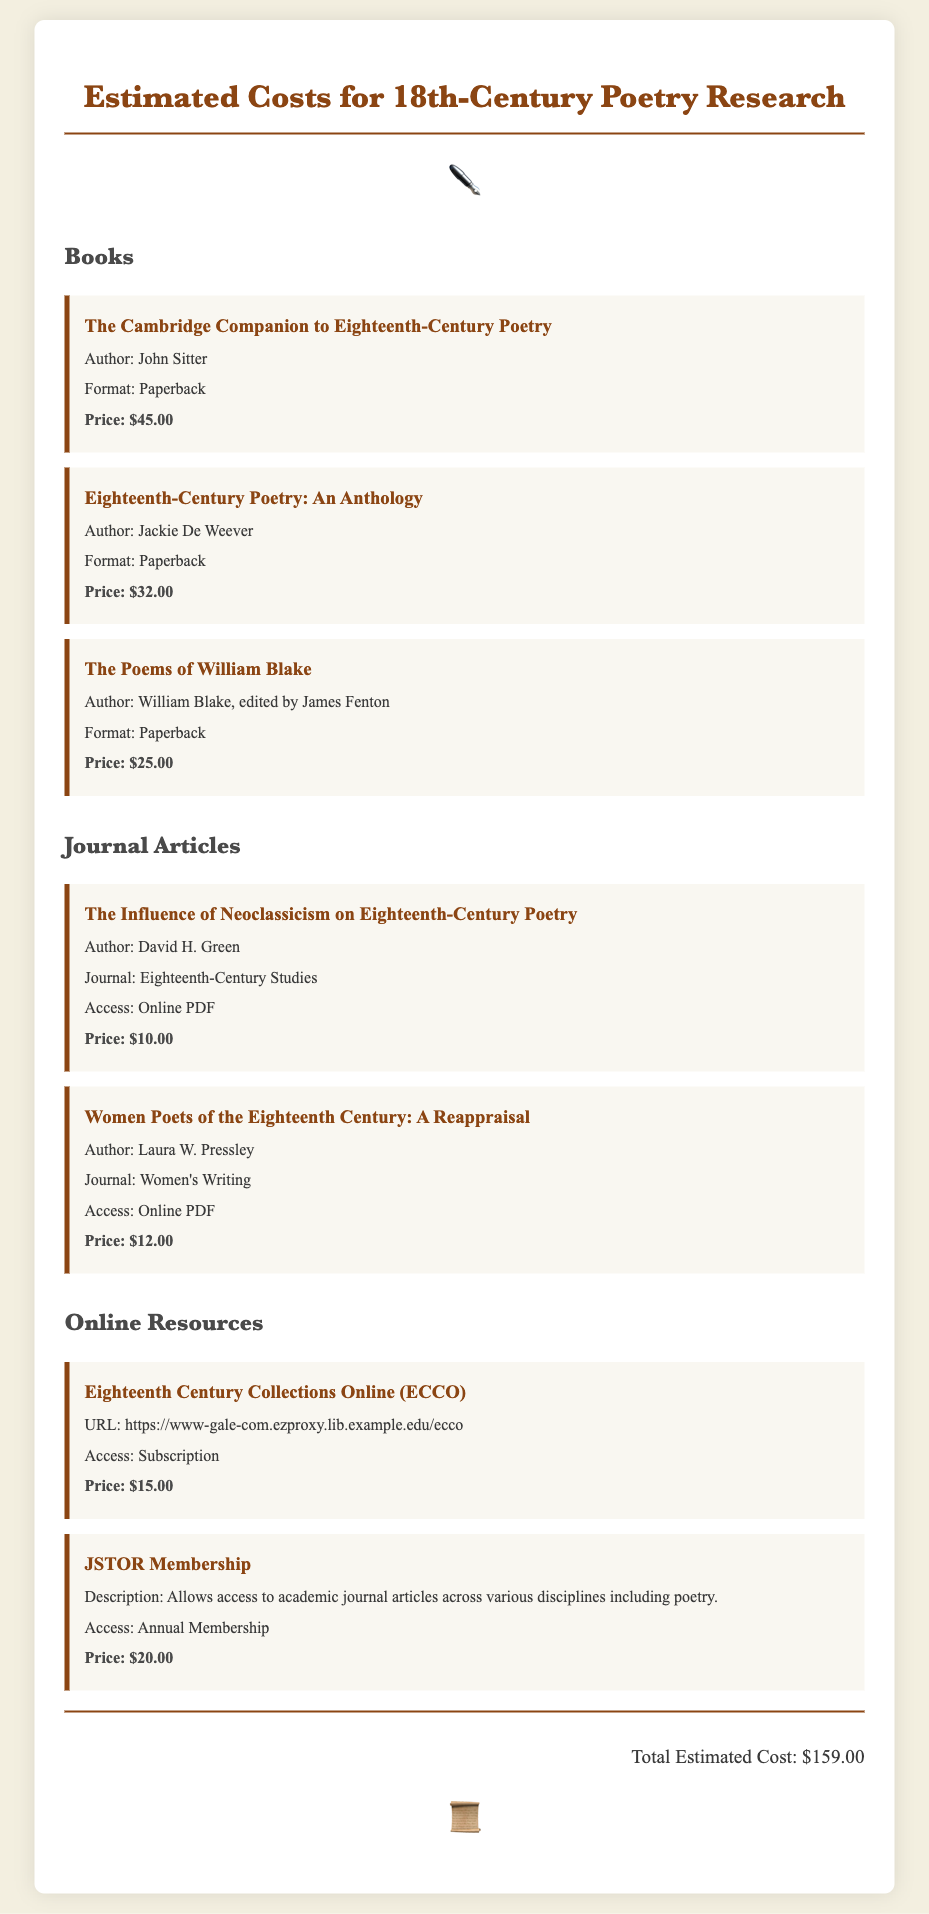What is the title of the first book listed? The first book listed is "The Cambridge Companion to Eighteenth-Century Poetry."
Answer: The Cambridge Companion to Eighteenth-Century Poetry Who is the author of "Women Poets of the Eighteenth Century: A Reappraisal"? The author of this article is Laura W. Pressley.
Answer: Laura W. Pressley What is the price of JSTOR Membership? The price listed for JSTOR Membership is $20.00.
Answer: $20.00 How many journal articles are mentioned in the document? There are two journal articles listed in the document.
Answer: 2 What is the total estimated cost for the research materials? The total estimated cost is calculated from all items listed, which is $159.00.
Answer: $159.00 What format is "The Poems of William Blake" available in? The format for "The Poems of William Blake" is listed as Paperback.
Answer: Paperback What is the URL for the Eighteenth Century Collections Online? The document provides the URL as https://www-gale-com.ezproxy.lib.example.edu/ecco.
Answer: https://www-gale-com.ezproxy.lib.example.edu/ecco Which journal article discusses Neoclassicism's influence? The article titled "The Influence of Neoclassicism on Eighteenth-Century Poetry" addresses this topic.
Answer: The Influence of Neoclassicism on Eighteenth-Century Poetry 